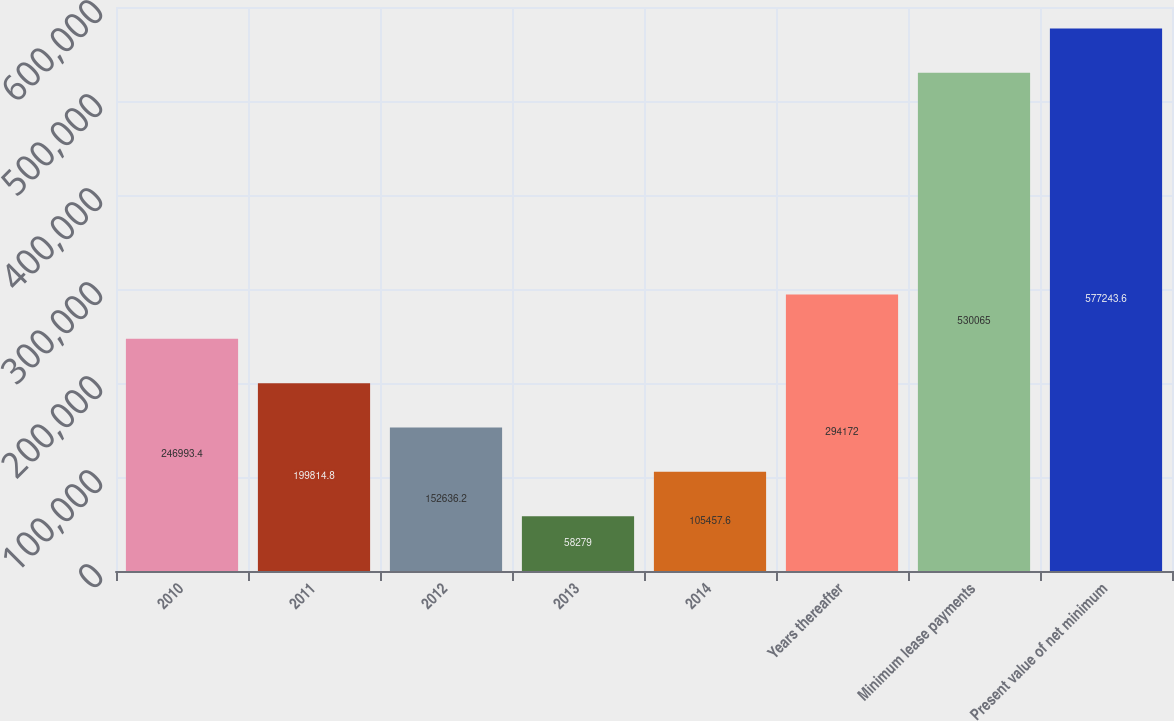Convert chart to OTSL. <chart><loc_0><loc_0><loc_500><loc_500><bar_chart><fcel>2010<fcel>2011<fcel>2012<fcel>2013<fcel>2014<fcel>Years thereafter<fcel>Minimum lease payments<fcel>Present value of net minimum<nl><fcel>246993<fcel>199815<fcel>152636<fcel>58279<fcel>105458<fcel>294172<fcel>530065<fcel>577244<nl></chart> 